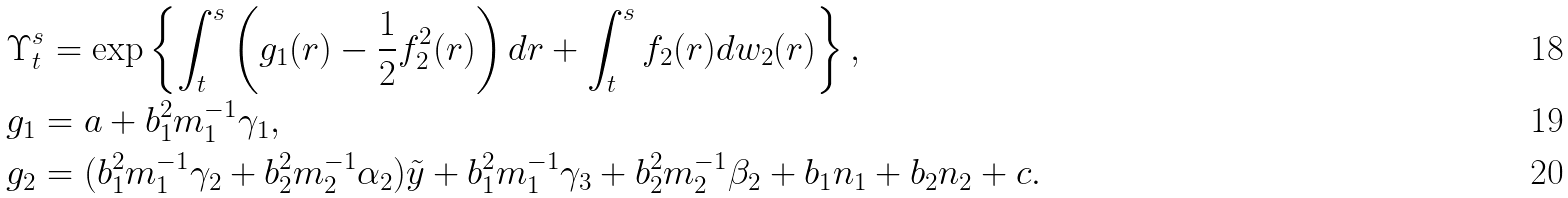Convert formula to latex. <formula><loc_0><loc_0><loc_500><loc_500>& \Upsilon _ { t } ^ { s } = \exp \left \{ \int _ { t } ^ { s } \left ( g _ { 1 } ( r ) - \frac { 1 } { 2 } f _ { 2 } ^ { 2 } ( r ) \right ) d r + \int _ { t } ^ { s } f _ { 2 } ( r ) d w _ { 2 } ( r ) \right \} , \\ & g _ { 1 } = a + b _ { 1 } ^ { 2 } m _ { 1 } ^ { - 1 } \gamma _ { 1 } , \\ & g _ { 2 } = ( b _ { 1 } ^ { 2 } m _ { 1 } ^ { - 1 } \gamma _ { 2 } + b _ { 2 } ^ { 2 } m _ { 2 } ^ { - 1 } \alpha _ { 2 } ) \tilde { y } + b _ { 1 } ^ { 2 } m _ { 1 } ^ { - 1 } \gamma _ { 3 } + b _ { 2 } ^ { 2 } m _ { 2 } ^ { - 1 } \beta _ { 2 } + b _ { 1 } n _ { 1 } + b _ { 2 } n _ { 2 } + c .</formula> 